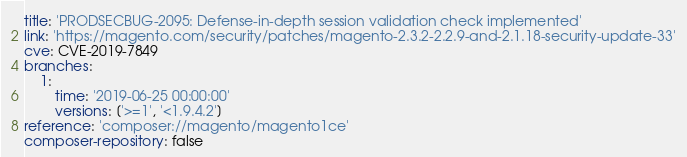<code> <loc_0><loc_0><loc_500><loc_500><_YAML_>title: 'PRODSECBUG-2095: Defense-in-depth session validation check implemented'
link: 'https://magento.com/security/patches/magento-2.3.2-2.2.9-and-2.1.18-security-update-33'
cve: CVE-2019-7849
branches:
    1:
        time: '2019-06-25 00:00:00'
        versions: ['>=1', '<1.9.4.2']
reference: 'composer://magento/magento1ce'
composer-repository: false
</code> 